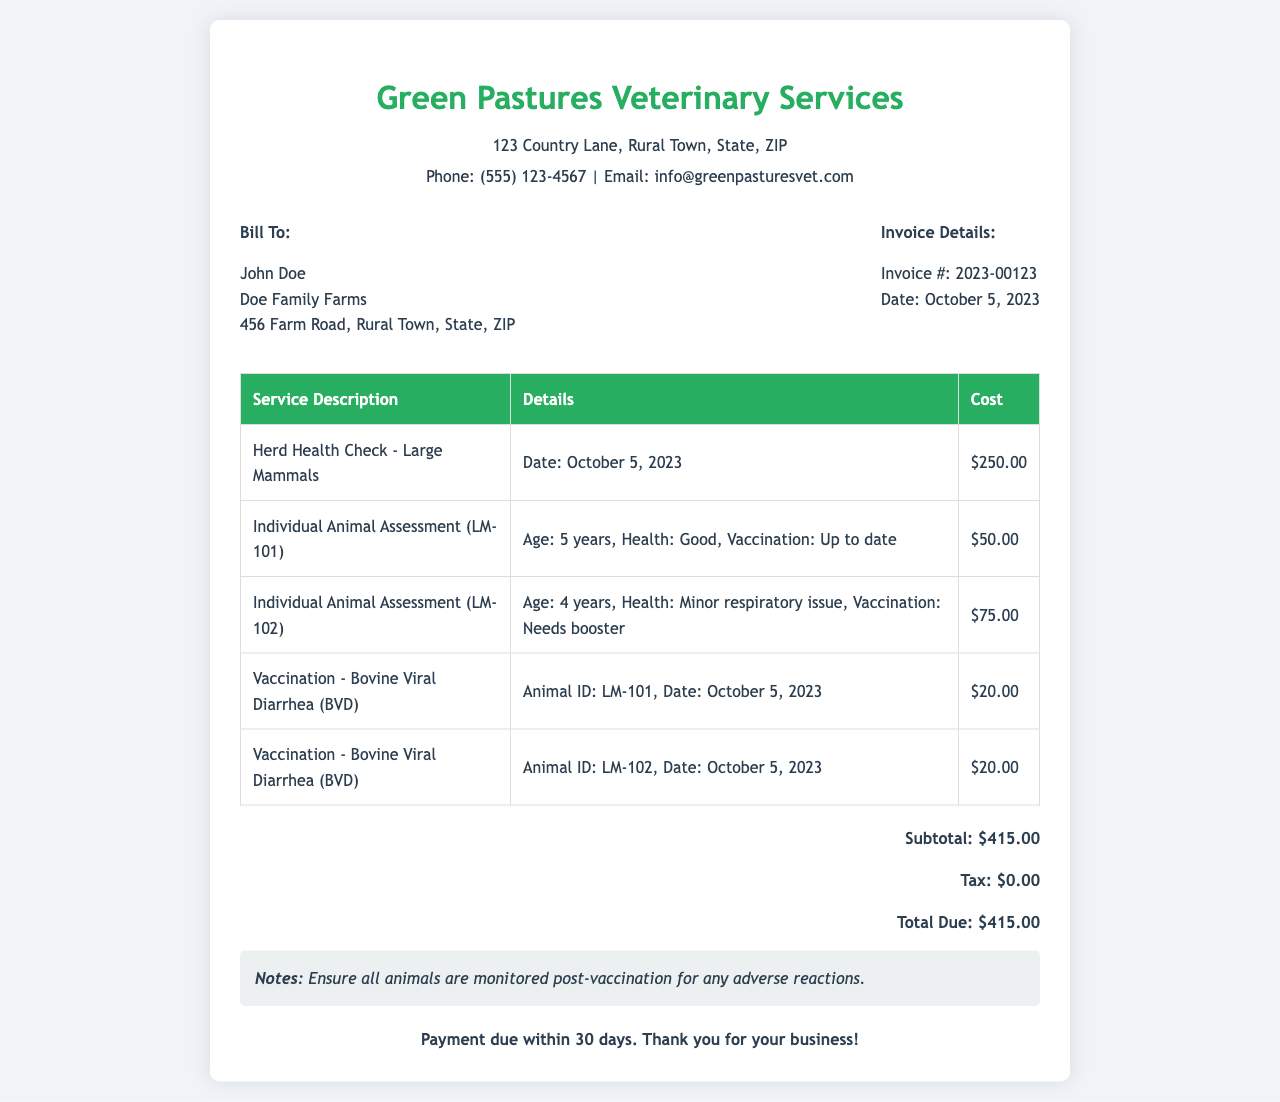What is the name of the veterinary service? The name of the veterinary service is listed at the top of the document, which is "Green Pastures Veterinary Services."
Answer: Green Pastures Veterinary Services What is the total due amount? The total due amount is calculated at the end of the invoice, which is stated as $415.00.
Answer: $415.00 Who is the invoice billed to? The billing information is provided in the client info section with the name "John Doe."
Answer: John Doe What is the date of the herd health check? The date of the herd health check is mentioned in the service description for the herd health check entry, which is "October 5, 2023."
Answer: October 5, 2023 What is the cost of the individual animal assessment for LM-102? The cost for the individual animal assessment for LM-102 is specified in the invoice table under the corresponding row.
Answer: $75.00 What vaccination was given to animal ID LM-101? The vaccination details for animal ID LM-101 are listed in the table section of the invoice as "Bovine Viral Diarrhea (BVD)."
Answer: Bovine Viral Diarrhea (BVD) What is the subtotal amount before tax? The subtotal amount is provided in the total summary section of the document, listed before tax calculation.
Answer: $415.00 What is the payment term for this invoice? The payment terms are mentioned at the bottom of the invoice, specifically noting the due timeline for payment.
Answer: Payment due within 30 days 